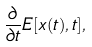Convert formula to latex. <formula><loc_0><loc_0><loc_500><loc_500>\frac { \partial } { \partial t } E [ { x } ( t ) , t ] ,</formula> 